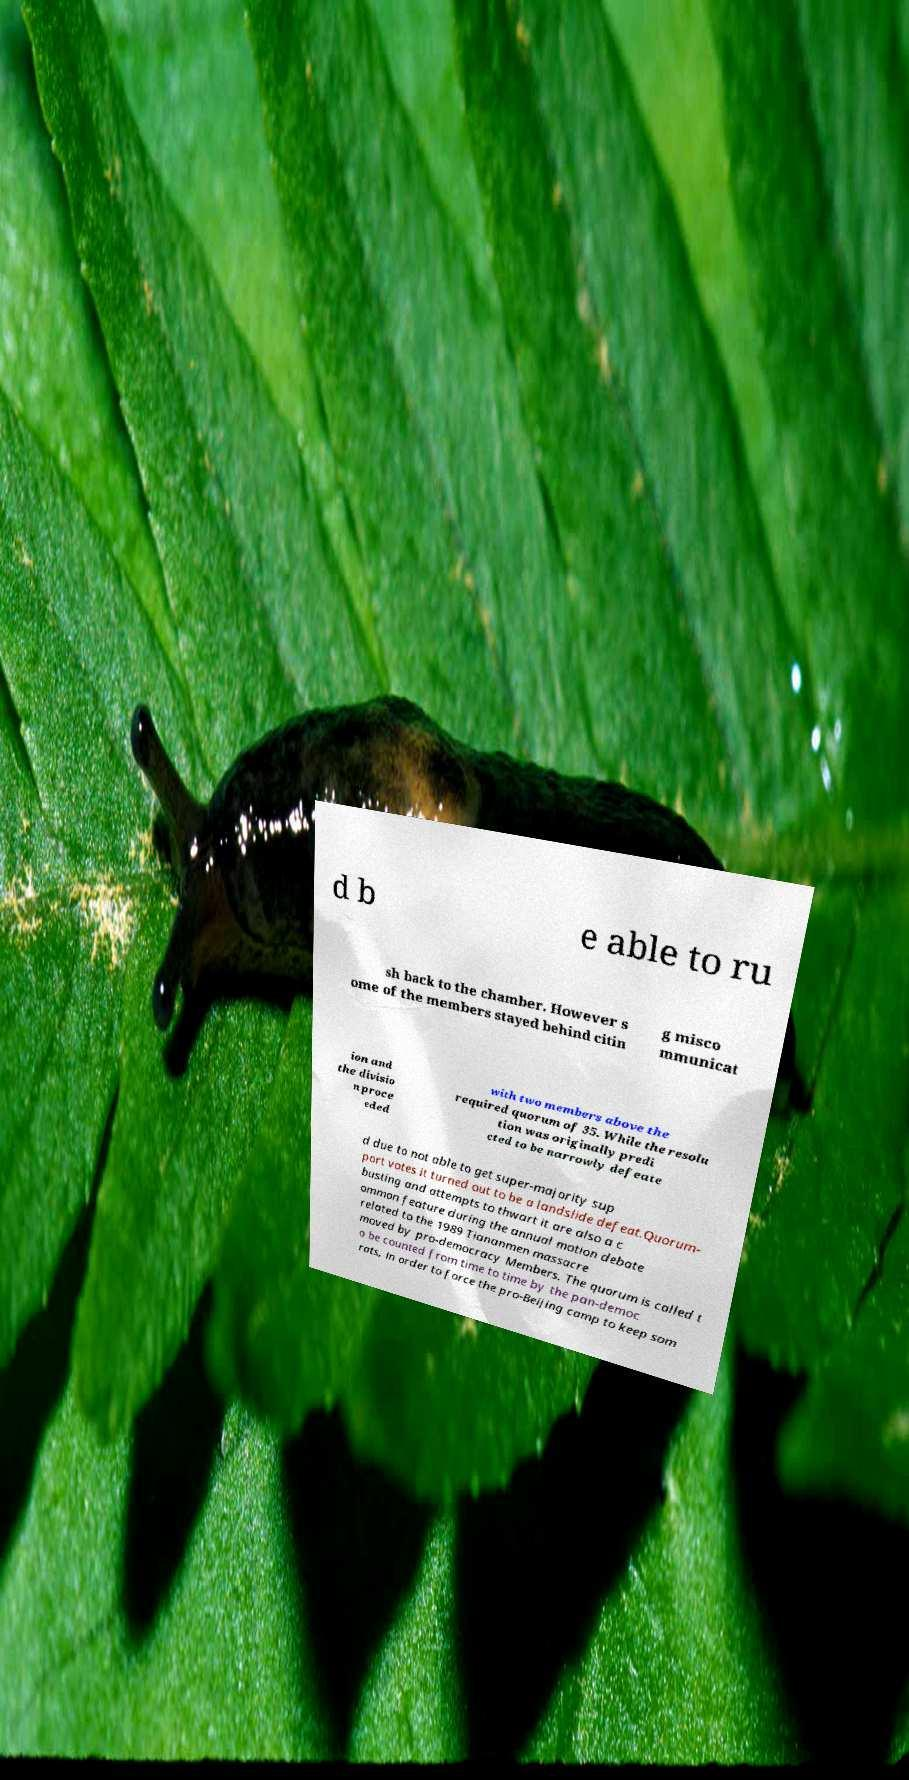Can you accurately transcribe the text from the provided image for me? d b e able to ru sh back to the chamber. However s ome of the members stayed behind citin g misco mmunicat ion and the divisio n proce eded with two members above the required quorum of 35. While the resolu tion was originally predi cted to be narrowly defeate d due to not able to get super-majority sup port votes it turned out to be a landslide defeat.Quorum- busting and attempts to thwart it are also a c ommon feature during the annual motion debate related to the 1989 Tiananmen massacre moved by pro-democracy Members. The quorum is called t o be counted from time to time by the pan-democ rats, in order to force the pro-Beijing camp to keep som 